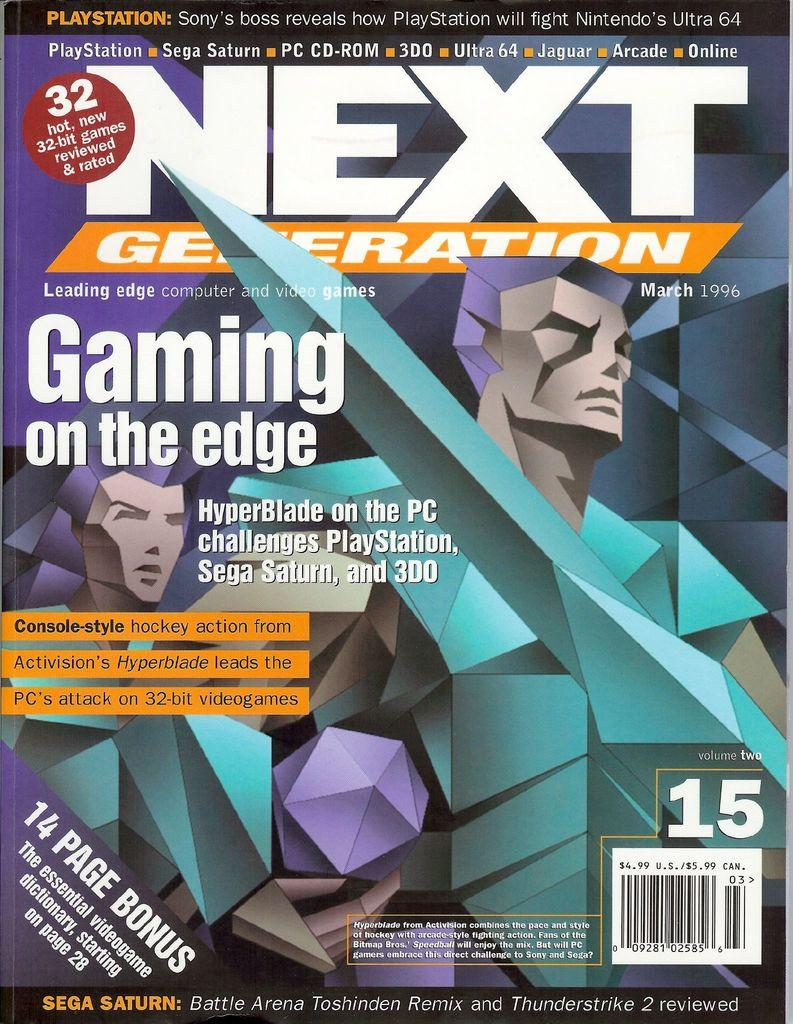<image>
Relay a brief, clear account of the picture shown. Next Generation magazine explores the subject of Gaming on the Edge. 